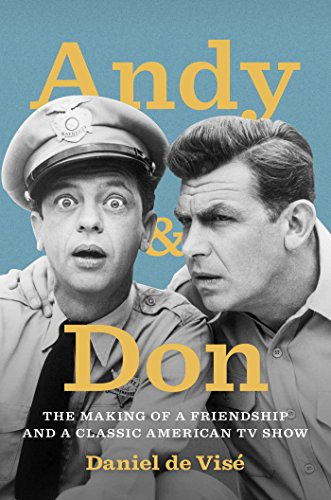Who wrote this book?
Answer the question using a single word or phrase. Daniel de Visé What is the title of this book? Andy and Don: The Making of a Friendship and a Classic American TV Show What is the genre of this book? Humor & Entertainment Is this book related to Humor & Entertainment? Yes Is this book related to Engineering & Transportation? No 